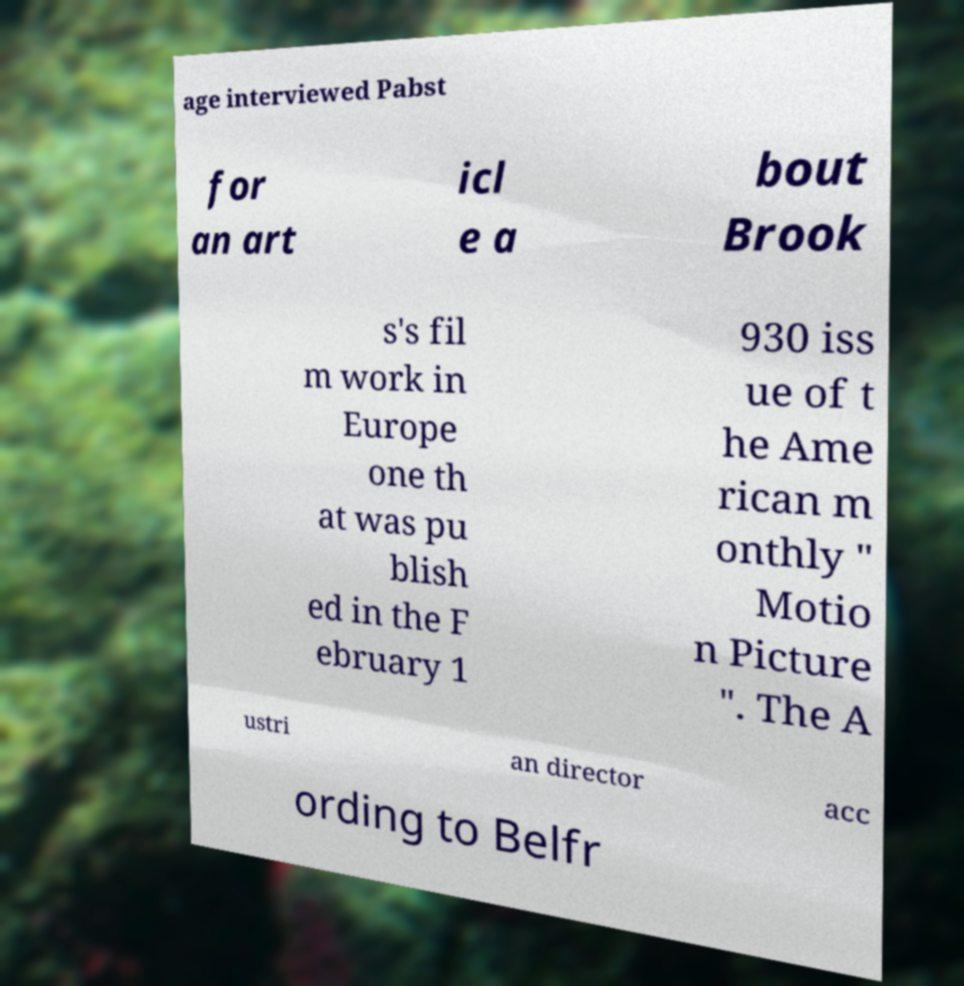Could you assist in decoding the text presented in this image and type it out clearly? age interviewed Pabst for an art icl e a bout Brook s's fil m work in Europe one th at was pu blish ed in the F ebruary 1 930 iss ue of t he Ame rican m onthly " Motio n Picture ". The A ustri an director acc ording to Belfr 